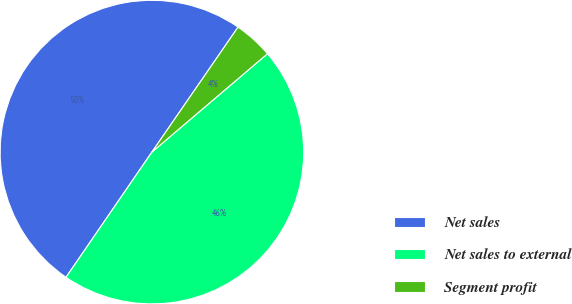Convert chart to OTSL. <chart><loc_0><loc_0><loc_500><loc_500><pie_chart><fcel>Net sales<fcel>Net sales to external<fcel>Segment profit<nl><fcel>50.03%<fcel>45.79%<fcel>4.17%<nl></chart> 